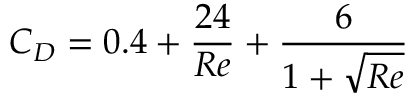<formula> <loc_0><loc_0><loc_500><loc_500>C _ { D } = 0 . 4 + \frac { 2 4 } { R e } + \frac { 6 } { 1 + \sqrt { R e } }</formula> 